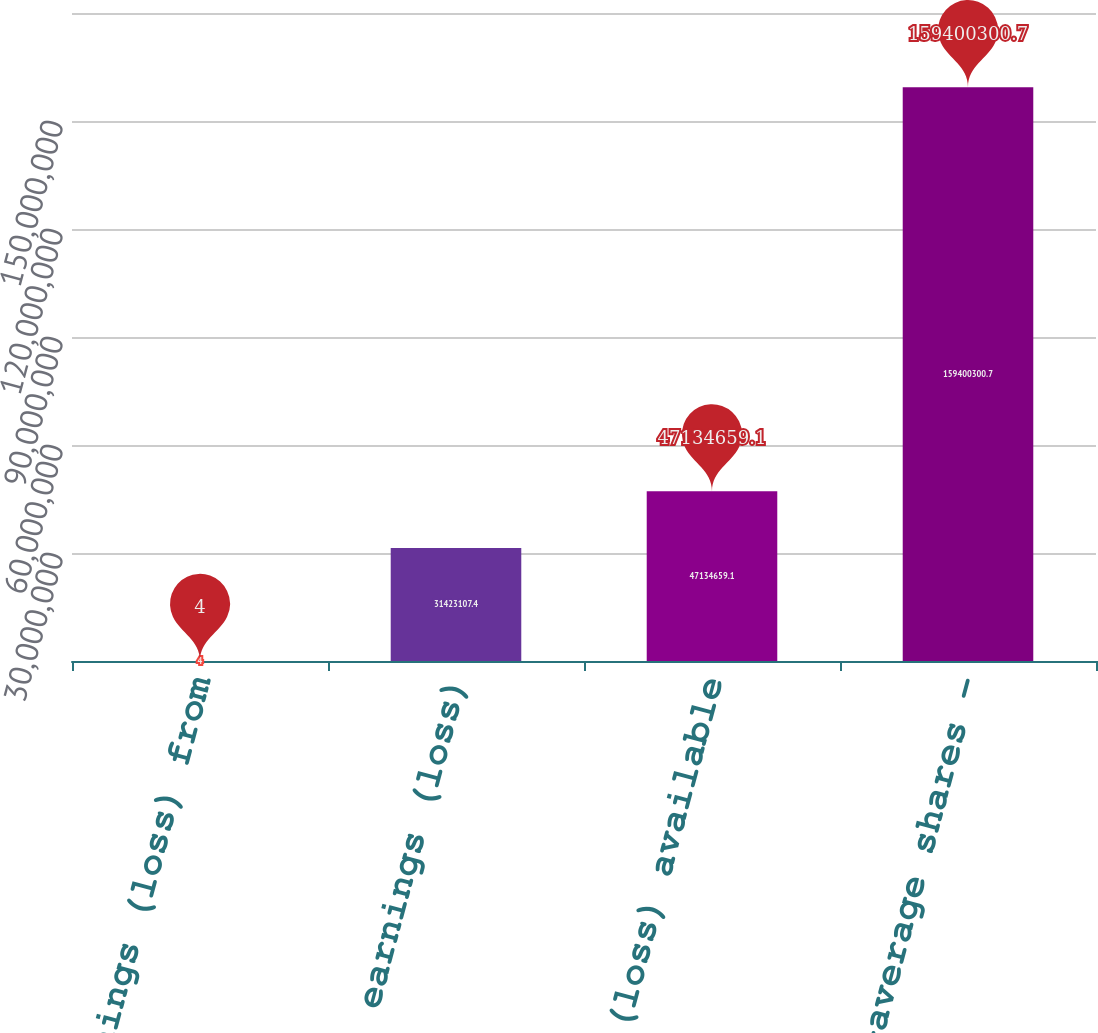<chart> <loc_0><loc_0><loc_500><loc_500><bar_chart><fcel>Earnings (loss) from<fcel>Net earnings (loss)<fcel>Net earnings (loss) available<fcel>Weighted-average shares -<nl><fcel>4<fcel>3.14231e+07<fcel>4.71347e+07<fcel>1.594e+08<nl></chart> 